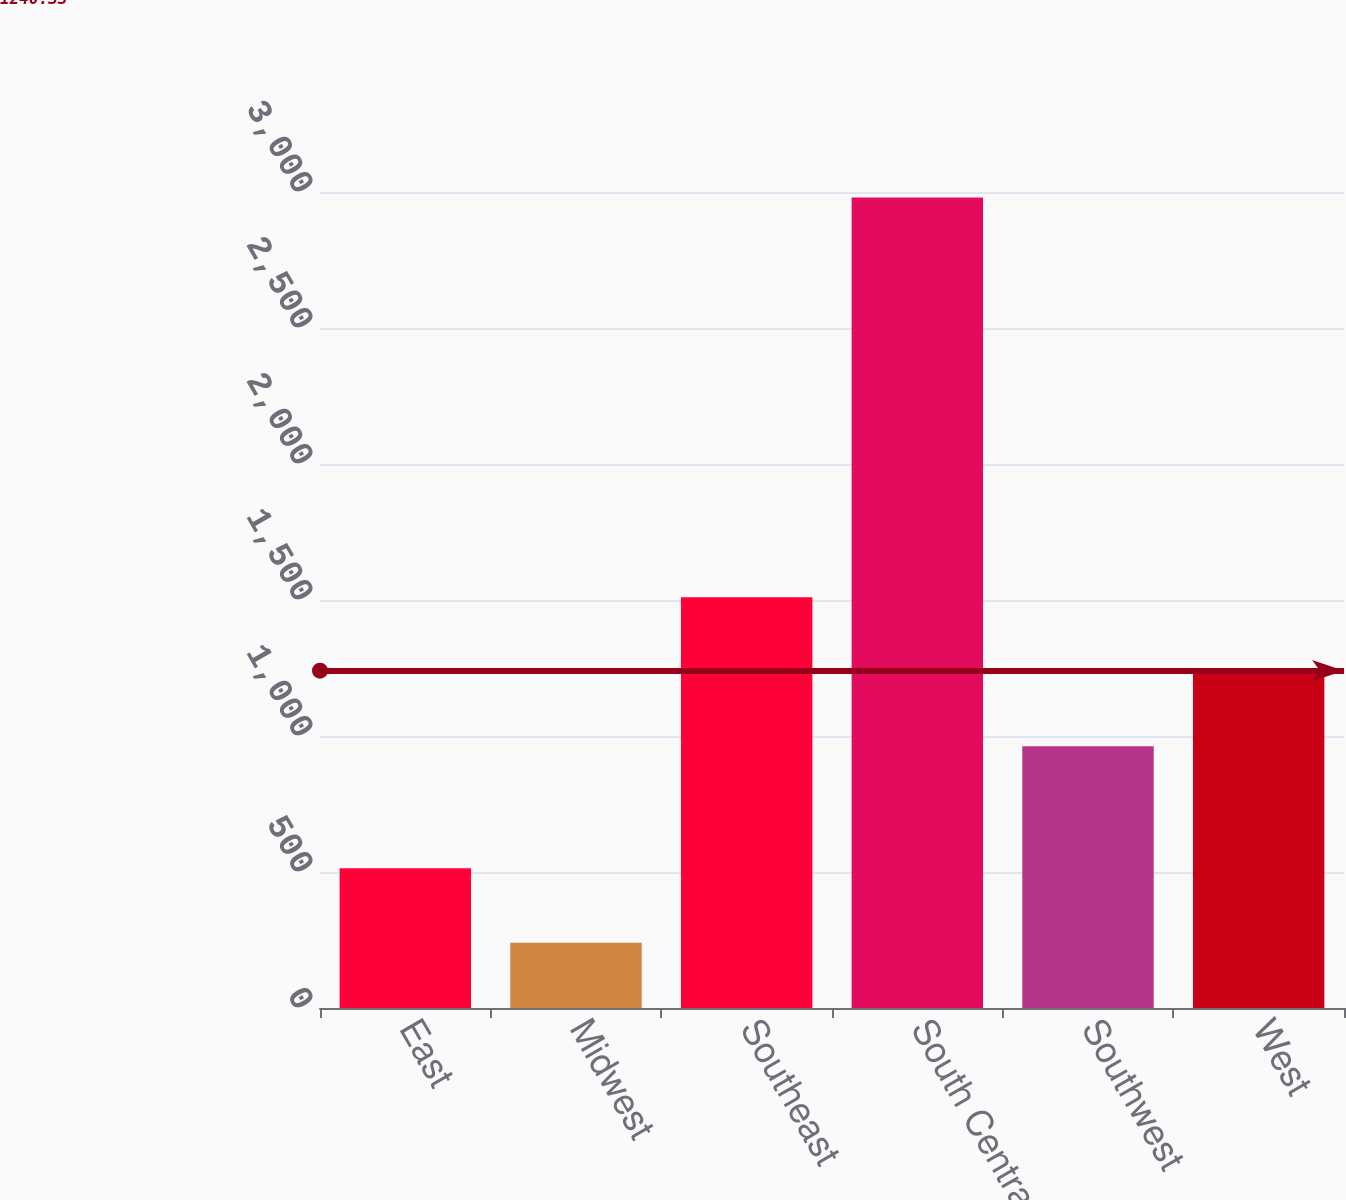Convert chart. <chart><loc_0><loc_0><loc_500><loc_500><bar_chart><fcel>East<fcel>Midwest<fcel>Southeast<fcel>South Central<fcel>Southwest<fcel>West<nl><fcel>514<fcel>240<fcel>1510<fcel>2980<fcel>962<fcel>1236<nl></chart> 